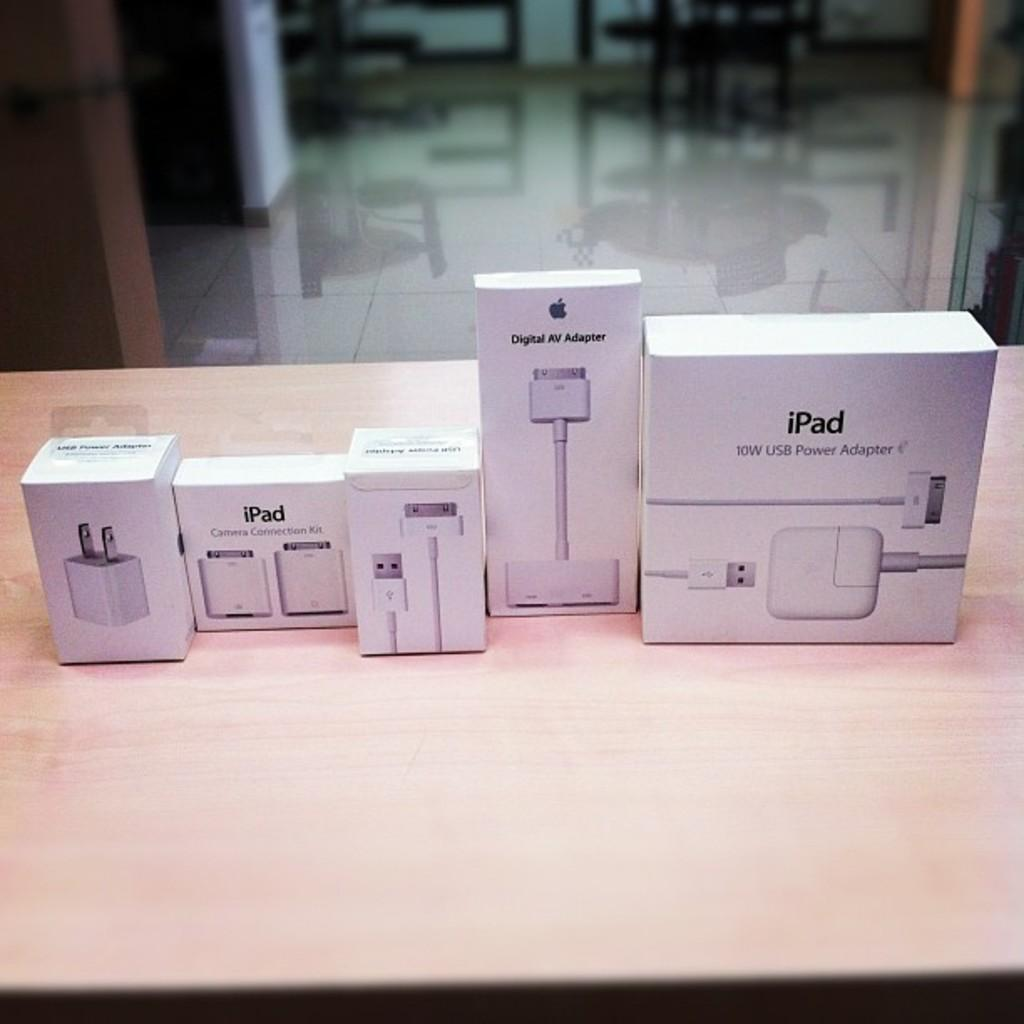<image>
Offer a succinct explanation of the picture presented. A group Apple products with some specifically for the iPad. 